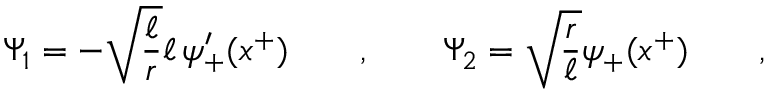<formula> <loc_0><loc_0><loc_500><loc_500>\Psi _ { 1 } = - \sqrt { \frac { \ell } { r } } \ell \, \psi _ { + } ^ { \prime } ( x ^ { + } ) \quad , \quad \Psi _ { 2 } = \sqrt { \frac { r } { \ell } } \psi _ { + } ( x ^ { + } ) \quad ,</formula> 